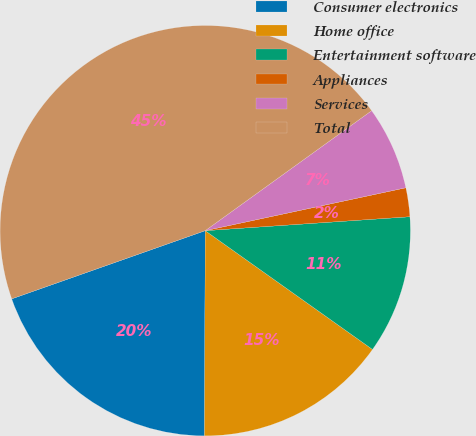Convert chart. <chart><loc_0><loc_0><loc_500><loc_500><pie_chart><fcel>Consumer electronics<fcel>Home office<fcel>Entertainment software<fcel>Appliances<fcel>Services<fcel>Total<nl><fcel>19.55%<fcel>15.23%<fcel>10.91%<fcel>2.27%<fcel>6.59%<fcel>45.45%<nl></chart> 